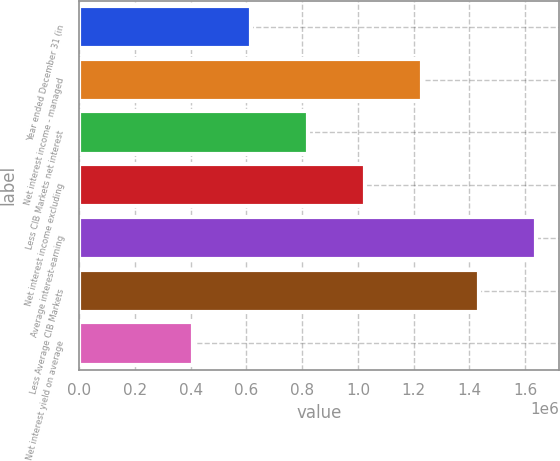<chart> <loc_0><loc_0><loc_500><loc_500><bar_chart><fcel>Year ended December 31 (in<fcel>Net interest income - managed<fcel>Less CIB Markets net interest<fcel>Net interest income excluding<fcel>Average interest-earning<fcel>Less Average CIB Markets<fcel>Net interest yield on average<nl><fcel>614729<fcel>1.22946e+06<fcel>819638<fcel>1.02455e+06<fcel>1.63927e+06<fcel>1.43437e+06<fcel>409820<nl></chart> 